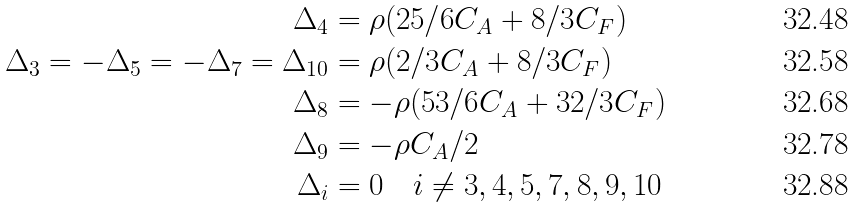<formula> <loc_0><loc_0><loc_500><loc_500>\Delta _ { 4 } & = \rho ( 2 5 / 6 C _ { A } + 8 / 3 C _ { F } ) \\ \Delta _ { 3 } = - \Delta _ { 5 } = - \Delta _ { 7 } = \Delta _ { 1 0 } & = \rho ( 2 / 3 C _ { A } + 8 / 3 C _ { F } ) \\ \Delta _ { 8 } & = - \rho ( 5 3 / 6 C _ { A } + 3 2 / 3 C _ { F } ) \\ \Delta _ { 9 } & = - \rho C _ { A } / 2 \\ \Delta _ { i } & = 0 \quad i \neq 3 , 4 , 5 , 7 , 8 , 9 , 1 0</formula> 